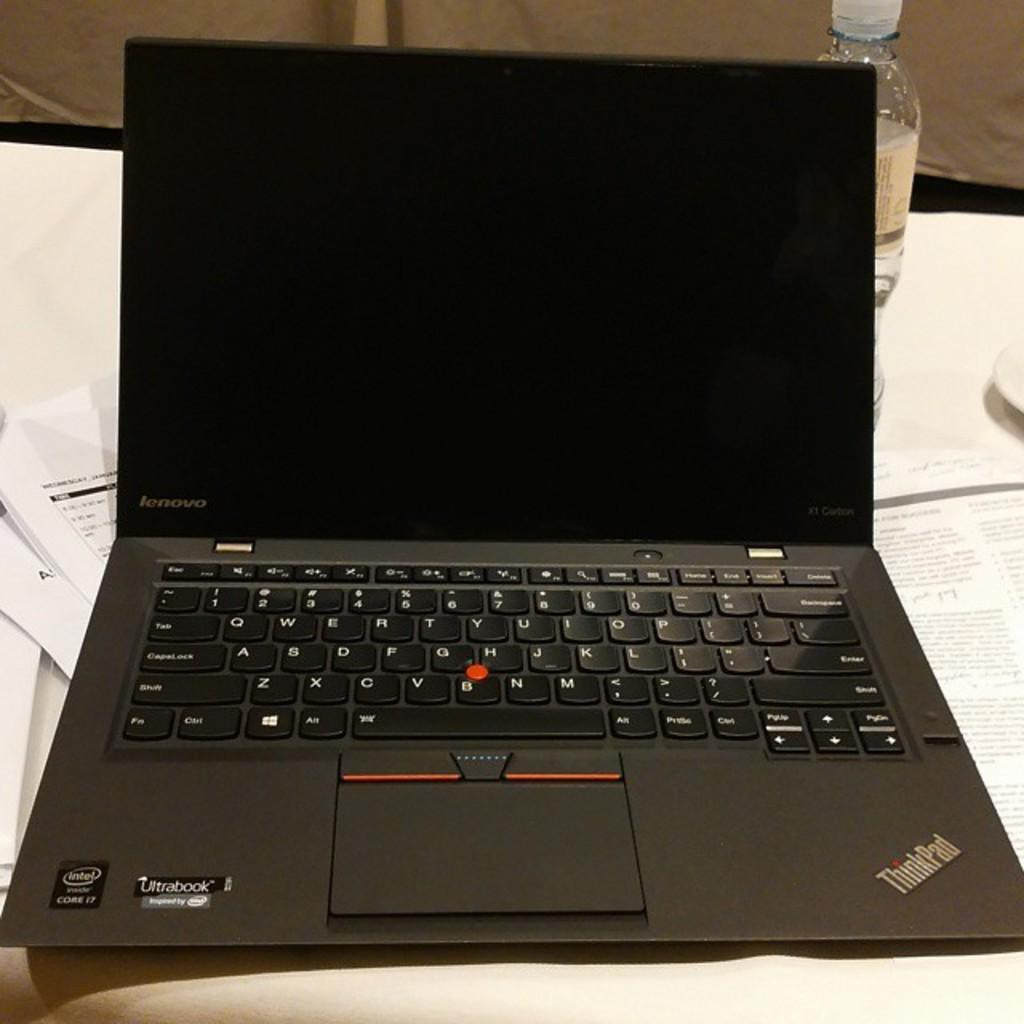<image>
Create a compact narrative representing the image presented. A Lenovo Thinkpad laptop is open and the screen is dark. 